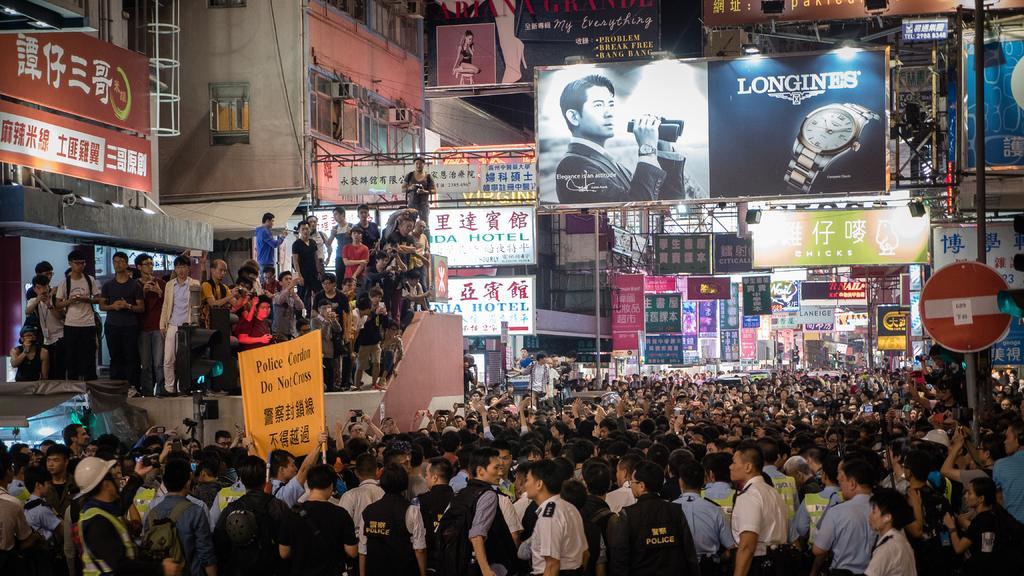In one or two sentences, can you explain what this image depicts? In this picture we can see there are groups of people standing and some people holding some objects. On the right side of the image there is a pole with a signboard. Behind the people there are boards, hoardings, cables and buildings. 